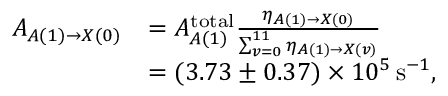<formula> <loc_0><loc_0><loc_500><loc_500>\begin{array} { r l } { A _ { A ( 1 ) \rightarrow X ( 0 ) } } & { = A _ { A ( 1 ) } ^ { t o t a l } \frac { { \eta } _ { A ( 1 ) \rightarrow X ( 0 ) } } { \sum _ { v = 0 } ^ { 1 1 } { \eta } _ { A ( 1 ) \rightarrow X ( v ) } } } \\ & { = ( 3 . 7 3 \pm 0 . 3 7 ) \times 1 0 ^ { 5 } \, s ^ { - 1 } , } \end{array}</formula> 